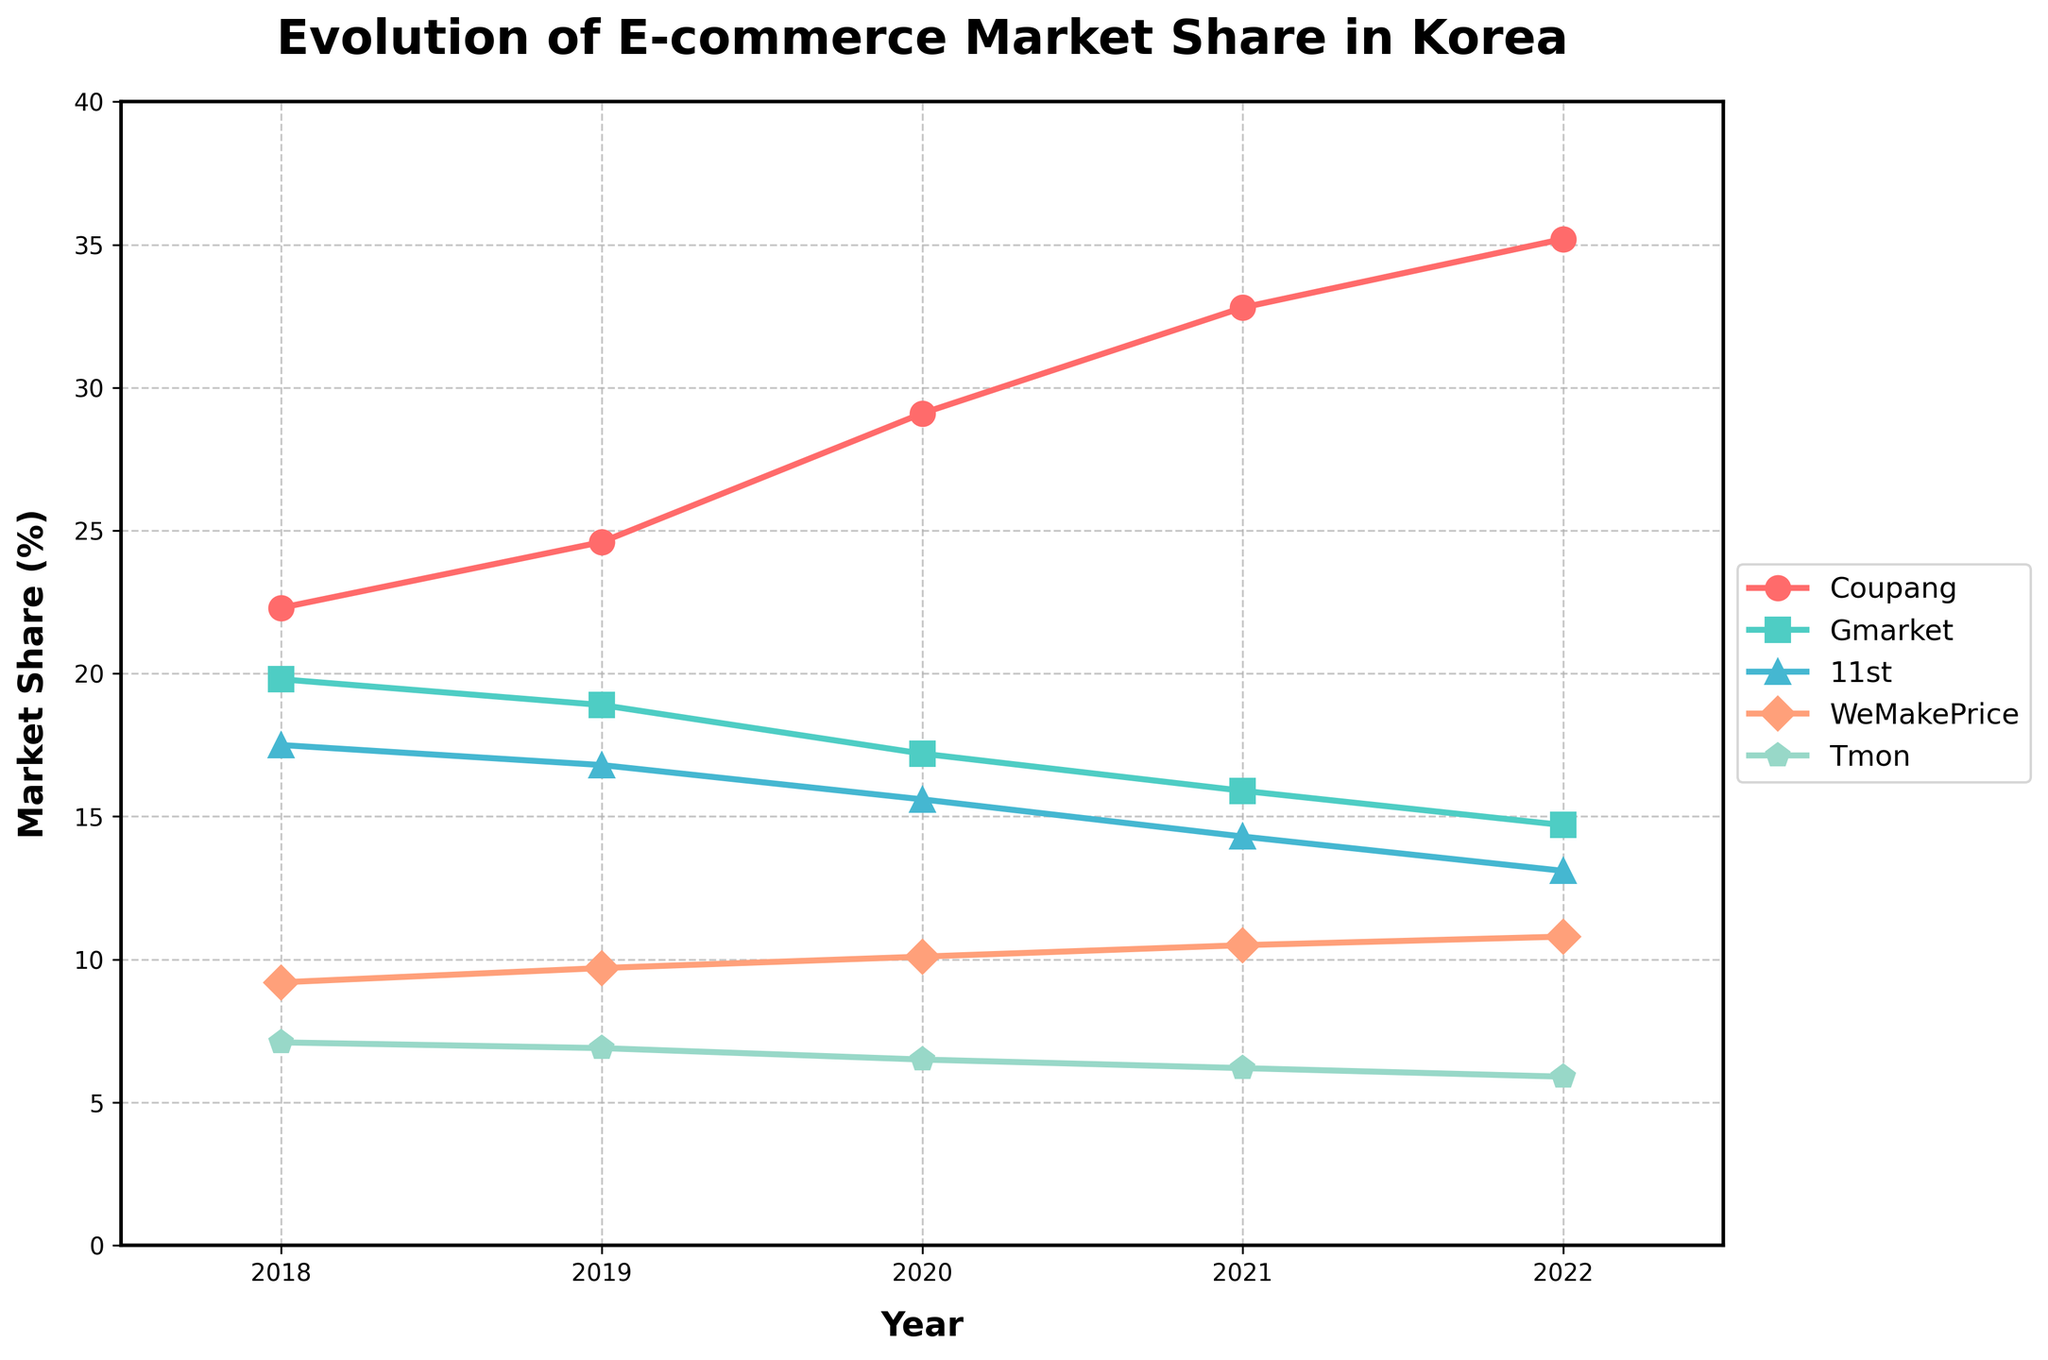Which company had the highest market share in 2022? By looking at the end of each line at the year 2022, Coupang's line is the highest among all companies.
Answer: Coupang How did Gmarket's market share change from 2018 to 2022? Subtract Gmarket's 2018 market share (19.8) from its 2022 market share (14.7): 14.7 - 19.8 = -5.1. Gmarket's market share decreased by 5.1%.
Answer: Decreased by 5.1% Which two companies had the closest market share in 2020? Checking the values for 2020, WeMakePrice (10.1) and Tmon (6.5) are relatively close, but Gmarket (17.2) and 11st (15.6) have the smallest difference. Subtract 11st's market share from Gmarket's: 17.2 - 15.6 = 1.6.
Answer: Gmarket and 11st Which company has shown the most consistent increase in market share over the 5 years? Coupang's line shows a continuous increase without any drops each year from 22.3 in 2018 to 35.2 in 2022.
Answer: Coupang What's the average market share of WeMakePrice over 5 years? Add WeMakePrice’s market shares from 2018 to 2022, then divide by 5: (9.2 + 9.7 + 10.1 + 10.5 + 10.8)/5 = 50.3/5 = 10.06.
Answer: 10.06 What is the overall trend for Tmon's market share from 2018 to 2022? By examining Tmon's market share values from 2018 (7.1) to 2022 (5.9), it shows a consistent decrease each year.
Answer: Decreasing Which year did Coupang surpass the 30% market share milestone? Find the year where Coupang first exceeds 30%. In 2021, Coupang's market share is 32.8.
Answer: 2021 Between which years did Coupang see the largest annual increase in market share? Calculate the annual differences: 
2018-2019: 24.6 - 22.3 = 2.3,
2019-2020: 29.1 - 24.6 = 4.5,
2020-2021: 32.8 - 29.1 = 3.7,
2021-2022: 35.2 - 32.8 = 2.4.
The largest increase is between 2019 and 2020 (4.5%).
Answer: 2019 and 2020 Which company had the smallest market share in 2021? Compare the market shares of all companies in 2021: Coupang (32.8), Gmarket (15.9), 11st (14.3), WeMakePrice (10.5), Tmon (6.2). Tmon has the smallest market share.
Answer: Tmon 